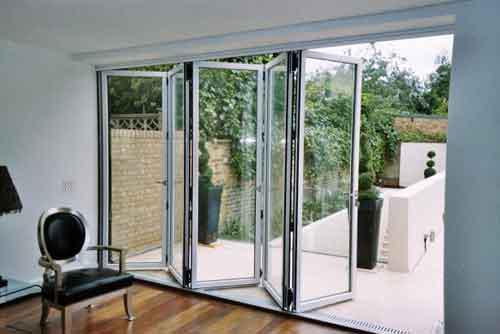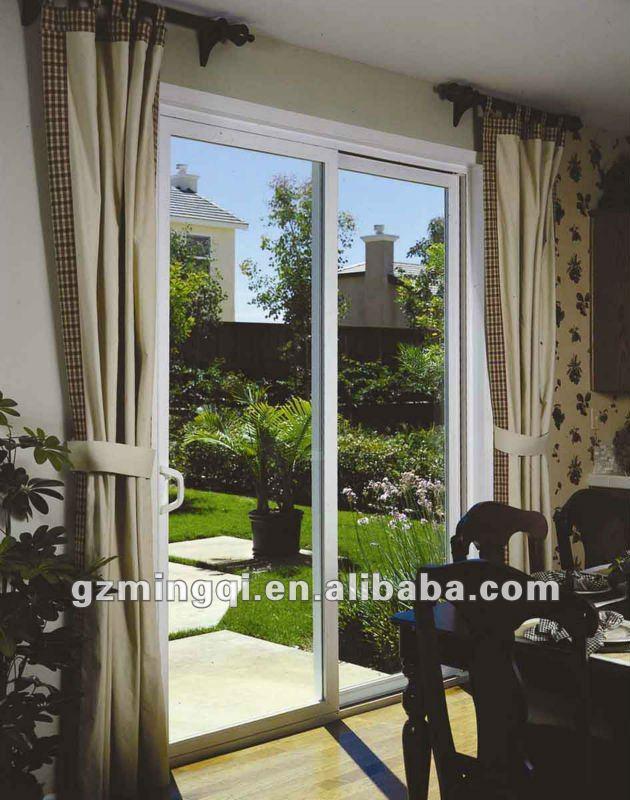The first image is the image on the left, the second image is the image on the right. For the images displayed, is the sentence "There are six glass panes in a row in the right image." factually correct? Answer yes or no. No. 